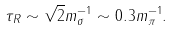Convert formula to latex. <formula><loc_0><loc_0><loc_500><loc_500>\tau _ { R } \sim \sqrt { 2 } m _ { \sigma } ^ { - 1 } \sim 0 . 3 m _ { \pi } ^ { - 1 } .</formula> 